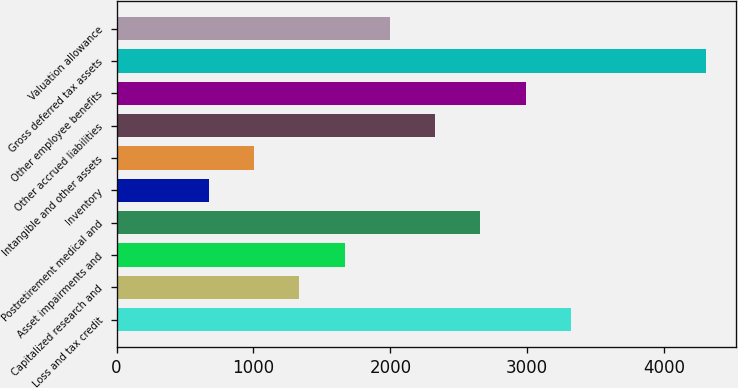Convert chart to OTSL. <chart><loc_0><loc_0><loc_500><loc_500><bar_chart><fcel>Loss and tax credit<fcel>Capitalized research and<fcel>Asset impairments and<fcel>Postretirement medical and<fcel>Inventory<fcel>Intangible and other assets<fcel>Other accrued liabilities<fcel>Other employee benefits<fcel>Gross deferred tax assets<fcel>Valuation allowance<nl><fcel>3318<fcel>1336.2<fcel>1666.5<fcel>2657.4<fcel>675.6<fcel>1005.9<fcel>2327.1<fcel>2987.7<fcel>4308.9<fcel>1996.8<nl></chart> 